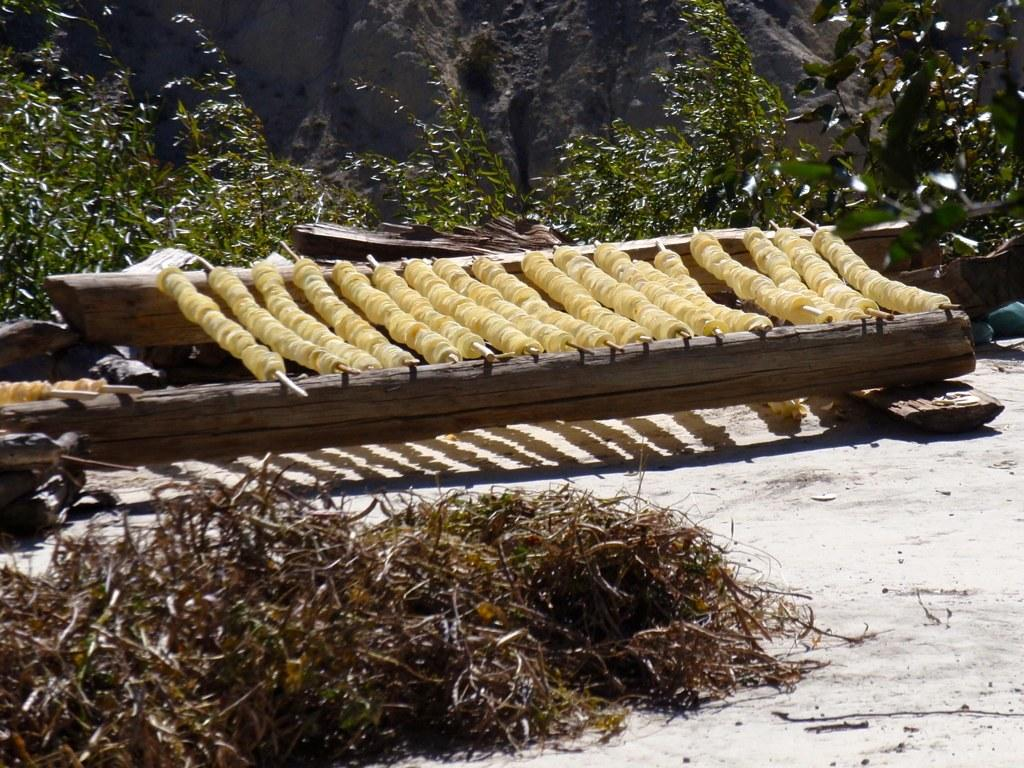What is the surface on which the food items are placed in the image? The food items are placed on wood in the image. What can be seen beneath the wood surface in the image? The ground is visible in the image. What type of vegetation is present in the image? Dried grass is present in the image. What is visible in the background of the image? There are plants visible in the background of the image. Can you find a receipt for the food items in the image? There is no receipt present in the image. 